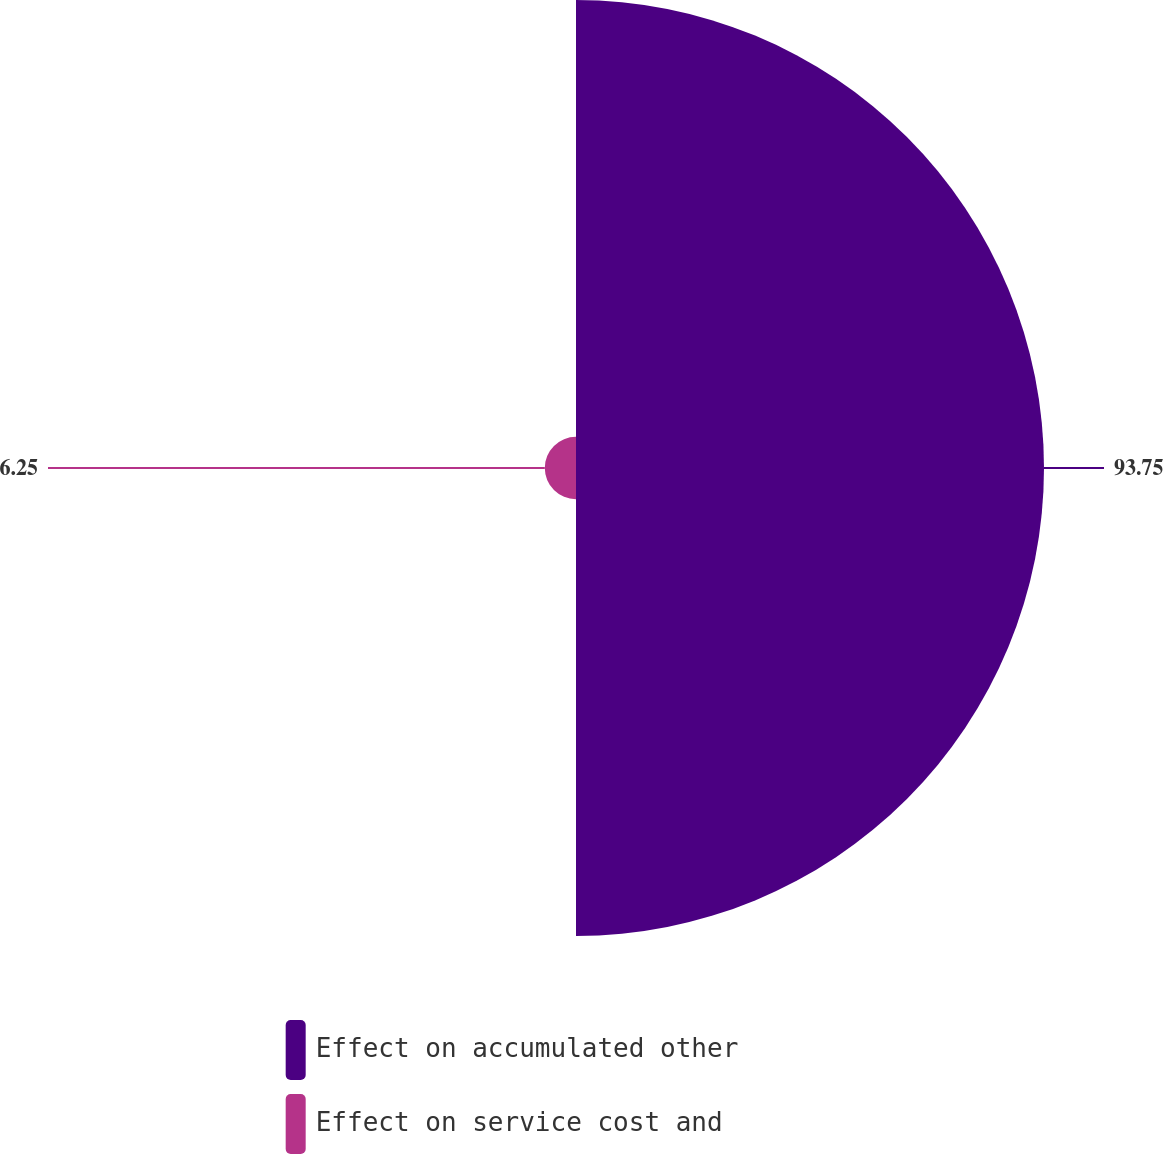Convert chart. <chart><loc_0><loc_0><loc_500><loc_500><pie_chart><fcel>Effect on accumulated other<fcel>Effect on service cost and<nl><fcel>93.75%<fcel>6.25%<nl></chart> 